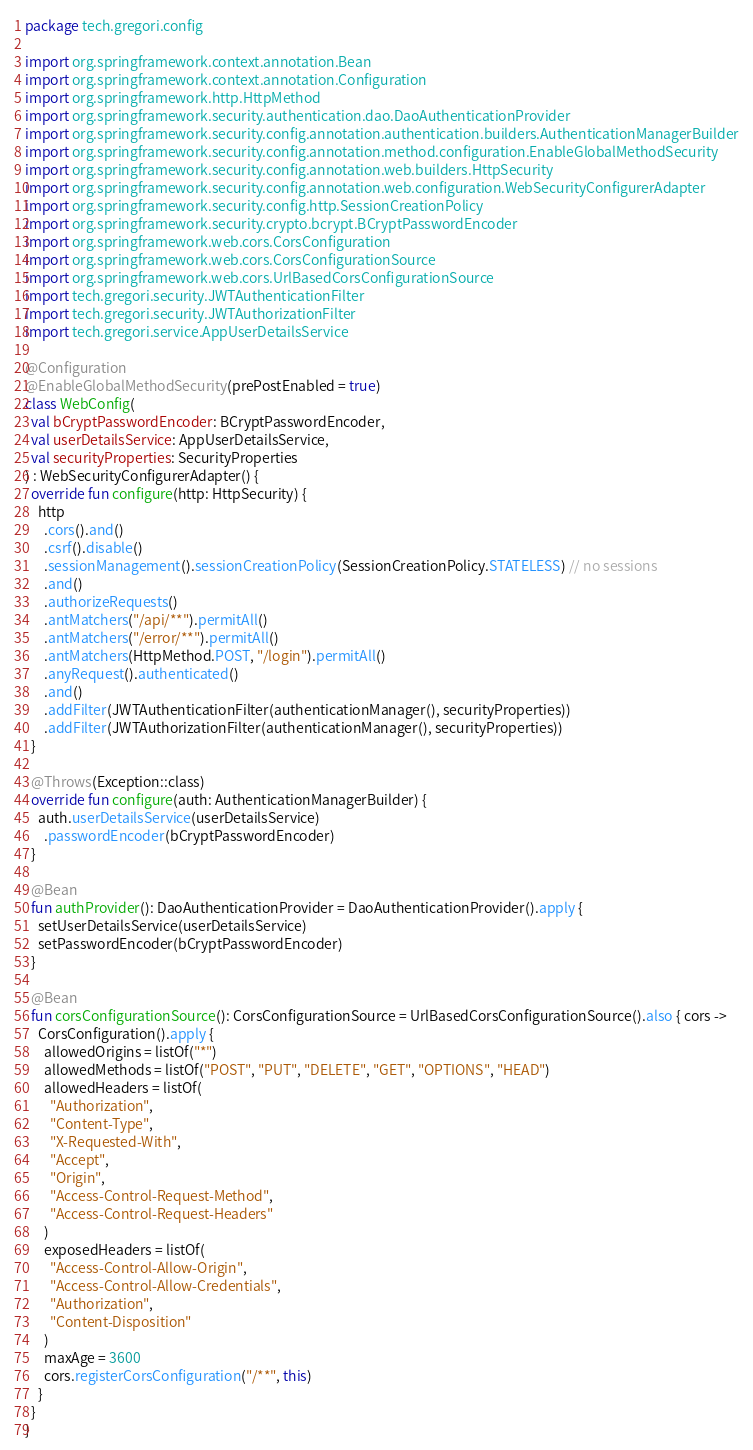Convert code to text. <code><loc_0><loc_0><loc_500><loc_500><_Kotlin_>package tech.gregori.config

import org.springframework.context.annotation.Bean
import org.springframework.context.annotation.Configuration
import org.springframework.http.HttpMethod
import org.springframework.security.authentication.dao.DaoAuthenticationProvider
import org.springframework.security.config.annotation.authentication.builders.AuthenticationManagerBuilder
import org.springframework.security.config.annotation.method.configuration.EnableGlobalMethodSecurity
import org.springframework.security.config.annotation.web.builders.HttpSecurity
import org.springframework.security.config.annotation.web.configuration.WebSecurityConfigurerAdapter
import org.springframework.security.config.http.SessionCreationPolicy
import org.springframework.security.crypto.bcrypt.BCryptPasswordEncoder
import org.springframework.web.cors.CorsConfiguration
import org.springframework.web.cors.CorsConfigurationSource
import org.springframework.web.cors.UrlBasedCorsConfigurationSource
import tech.gregori.security.JWTAuthenticationFilter
import tech.gregori.security.JWTAuthorizationFilter
import tech.gregori.service.AppUserDetailsService

@Configuration
@EnableGlobalMethodSecurity(prePostEnabled = true)
class WebConfig(
  val bCryptPasswordEncoder: BCryptPasswordEncoder,
  val userDetailsService: AppUserDetailsService,
  val securityProperties: SecurityProperties
) : WebSecurityConfigurerAdapter() {
  override fun configure(http: HttpSecurity) {
    http
      .cors().and()
      .csrf().disable()
      .sessionManagement().sessionCreationPolicy(SessionCreationPolicy.STATELESS) // no sessions
      .and()
      .authorizeRequests()
      .antMatchers("/api/**").permitAll()
      .antMatchers("/error/**").permitAll()
      .antMatchers(HttpMethod.POST, "/login").permitAll()
      .anyRequest().authenticated()
      .and()
      .addFilter(JWTAuthenticationFilter(authenticationManager(), securityProperties))
      .addFilter(JWTAuthorizationFilter(authenticationManager(), securityProperties))
  }

  @Throws(Exception::class)
  override fun configure(auth: AuthenticationManagerBuilder) {
    auth.userDetailsService(userDetailsService)
      .passwordEncoder(bCryptPasswordEncoder)
  }

  @Bean
  fun authProvider(): DaoAuthenticationProvider = DaoAuthenticationProvider().apply {
    setUserDetailsService(userDetailsService)
    setPasswordEncoder(bCryptPasswordEncoder)
  }

  @Bean
  fun corsConfigurationSource(): CorsConfigurationSource = UrlBasedCorsConfigurationSource().also { cors ->
    CorsConfiguration().apply {
      allowedOrigins = listOf("*")
      allowedMethods = listOf("POST", "PUT", "DELETE", "GET", "OPTIONS", "HEAD")
      allowedHeaders = listOf(
        "Authorization",
        "Content-Type",
        "X-Requested-With",
        "Accept",
        "Origin",
        "Access-Control-Request-Method",
        "Access-Control-Request-Headers"
      )
      exposedHeaders = listOf(
        "Access-Control-Allow-Origin",
        "Access-Control-Allow-Credentials",
        "Authorization",
        "Content-Disposition"
      )
      maxAge = 3600
      cors.registerCorsConfiguration("/**", this)
    }
  }
}
</code> 